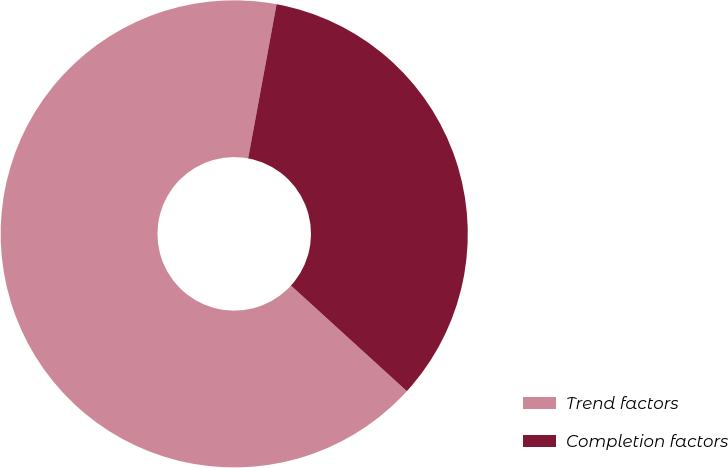<chart> <loc_0><loc_0><loc_500><loc_500><pie_chart><fcel>Trend factors<fcel>Completion factors<nl><fcel>66.14%<fcel>33.86%<nl></chart> 